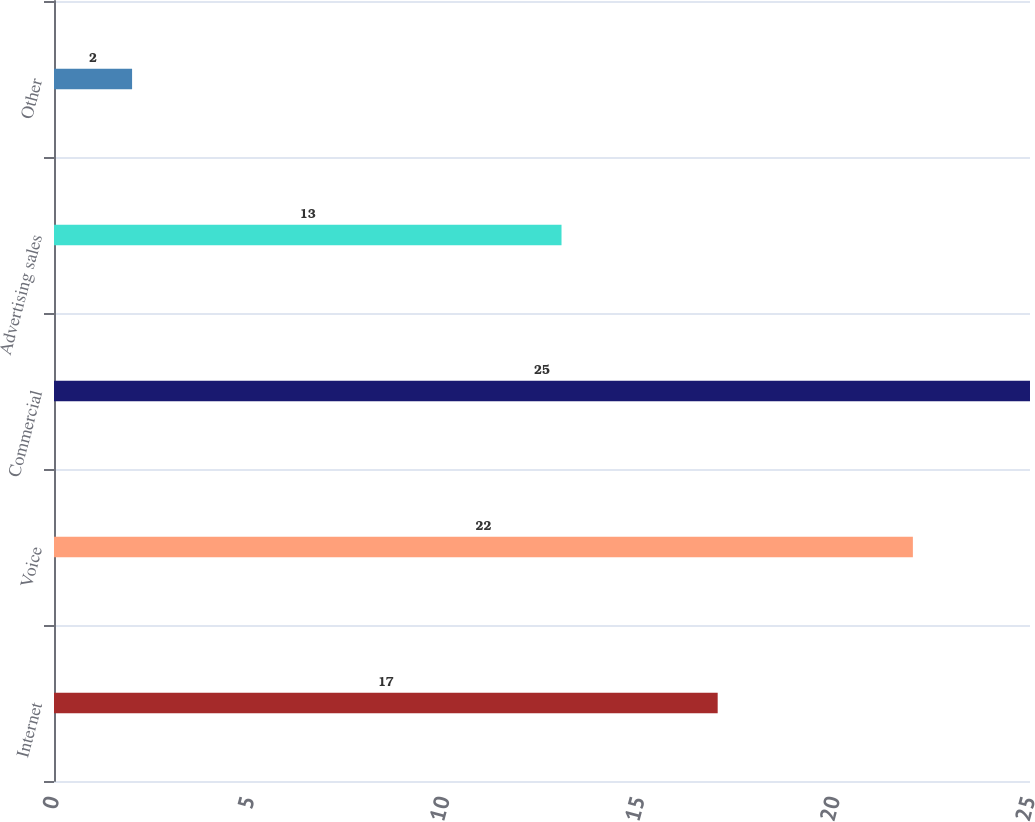Convert chart. <chart><loc_0><loc_0><loc_500><loc_500><bar_chart><fcel>Internet<fcel>Voice<fcel>Commercial<fcel>Advertising sales<fcel>Other<nl><fcel>17<fcel>22<fcel>25<fcel>13<fcel>2<nl></chart> 